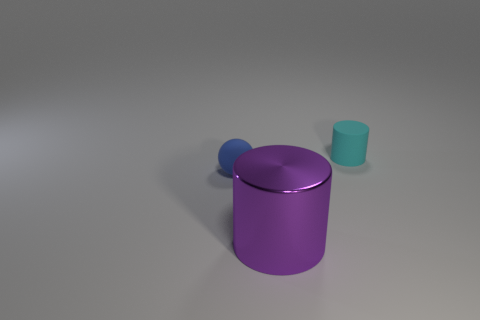Add 3 tiny gray balls. How many objects exist? 6 Subtract all cyan cylinders. How many cylinders are left? 1 Subtract all cylinders. How many objects are left? 1 Subtract 1 spheres. How many spheres are left? 0 Subtract all gray cylinders. Subtract all gray cubes. How many cylinders are left? 2 Subtract all gray spheres. How many purple cylinders are left? 1 Subtract all tiny blue cylinders. Subtract all large cylinders. How many objects are left? 2 Add 1 purple objects. How many purple objects are left? 2 Add 2 large cylinders. How many large cylinders exist? 3 Subtract 0 brown spheres. How many objects are left? 3 